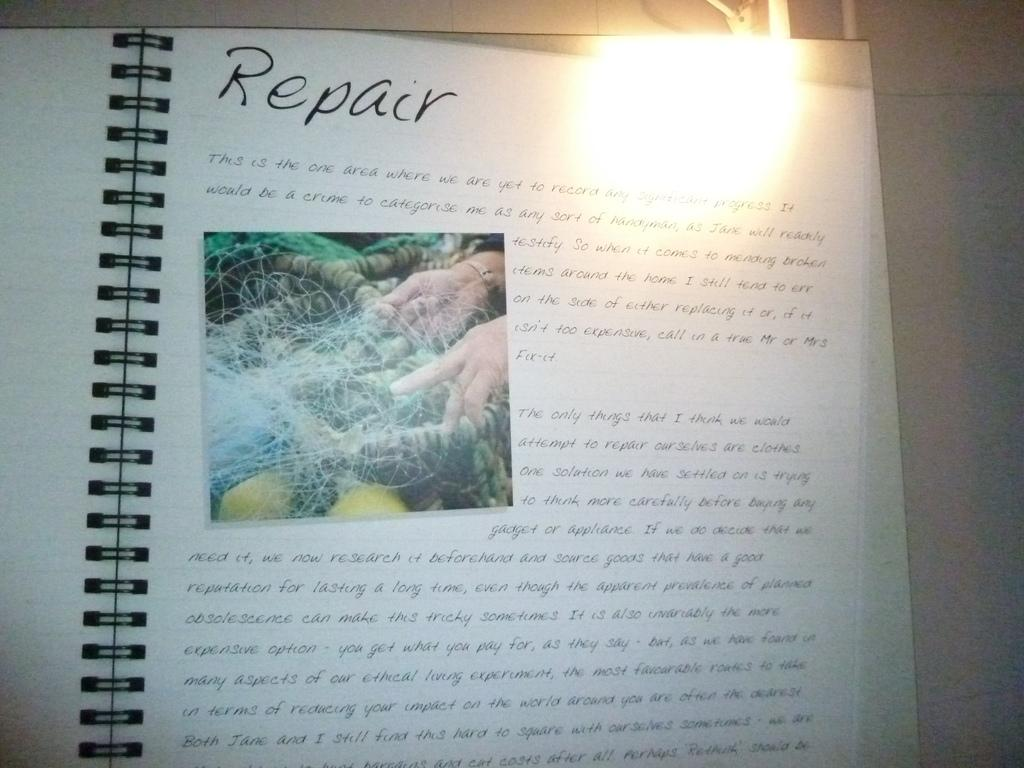<image>
Describe the image concisely. an open book to the word Repair has other words written too 